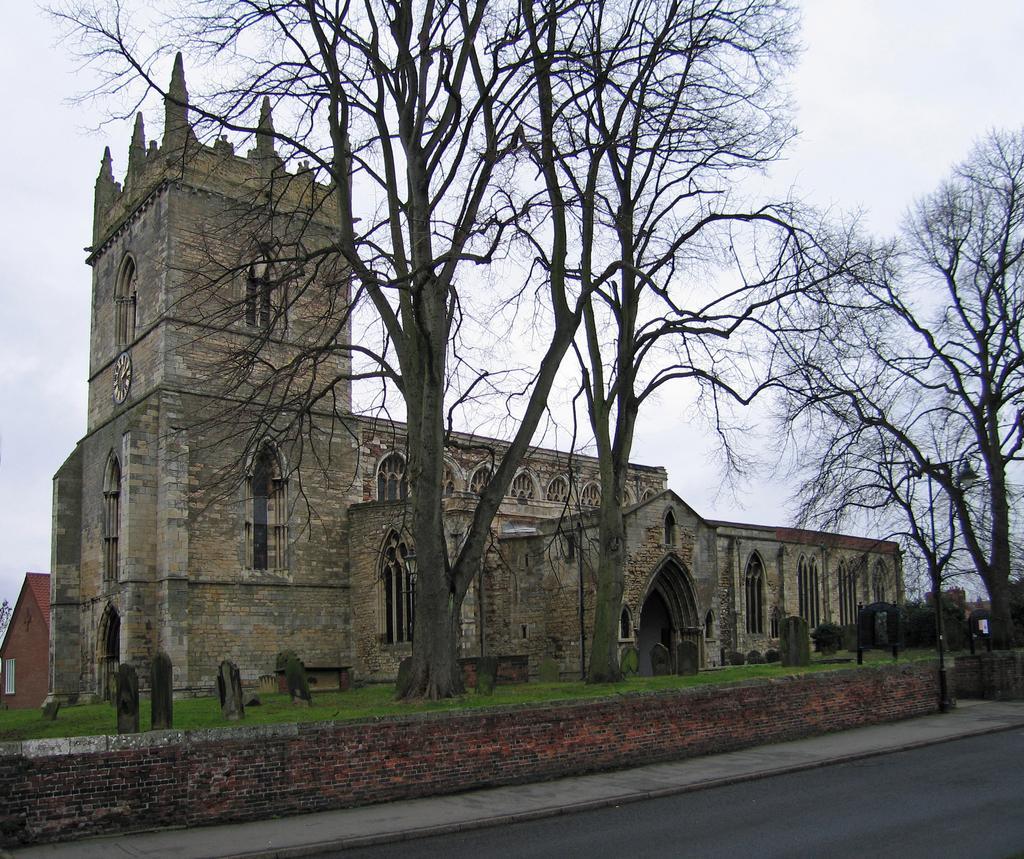Please provide a concise description of this image. In this image we can see the church, trees, graveyard stones and also the wall. In the background we can see the cloudy sky. At the bottom we can see the road. 